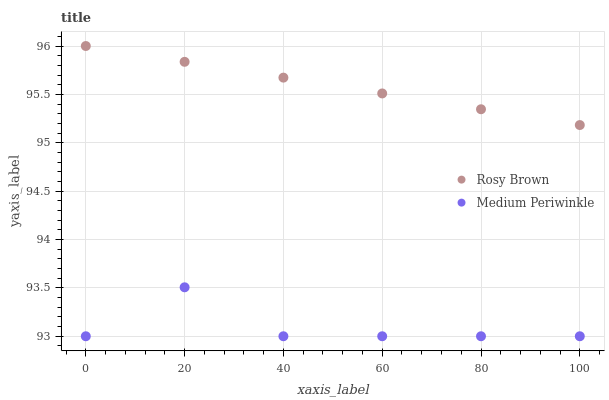Does Medium Periwinkle have the minimum area under the curve?
Answer yes or no. Yes. Does Rosy Brown have the maximum area under the curve?
Answer yes or no. Yes. Does Medium Periwinkle have the maximum area under the curve?
Answer yes or no. No. Is Rosy Brown the smoothest?
Answer yes or no. Yes. Is Medium Periwinkle the roughest?
Answer yes or no. Yes. Is Medium Periwinkle the smoothest?
Answer yes or no. No. Does Medium Periwinkle have the lowest value?
Answer yes or no. Yes. Does Rosy Brown have the highest value?
Answer yes or no. Yes. Does Medium Periwinkle have the highest value?
Answer yes or no. No. Is Medium Periwinkle less than Rosy Brown?
Answer yes or no. Yes. Is Rosy Brown greater than Medium Periwinkle?
Answer yes or no. Yes. Does Medium Periwinkle intersect Rosy Brown?
Answer yes or no. No. 